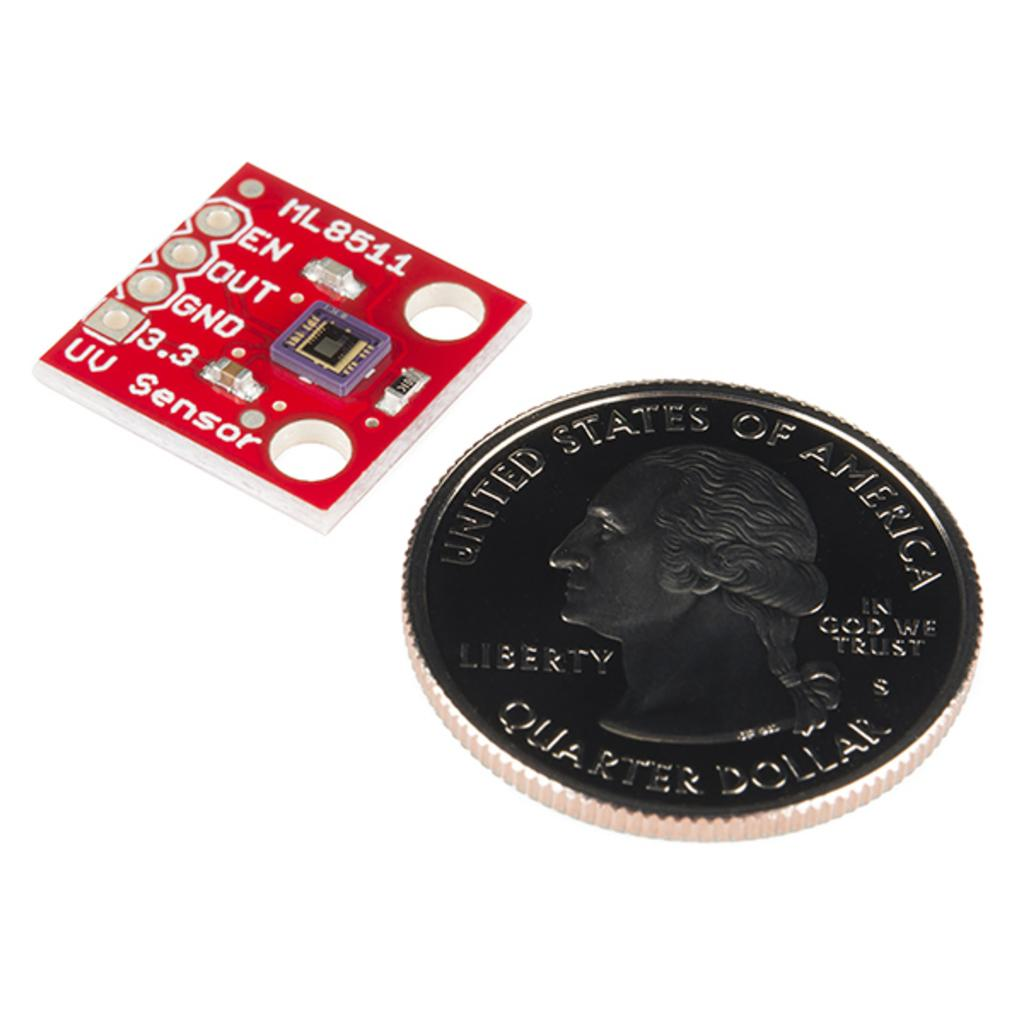<image>
Provide a brief description of the given image. An American coin that is worth a "quarter dollar". 